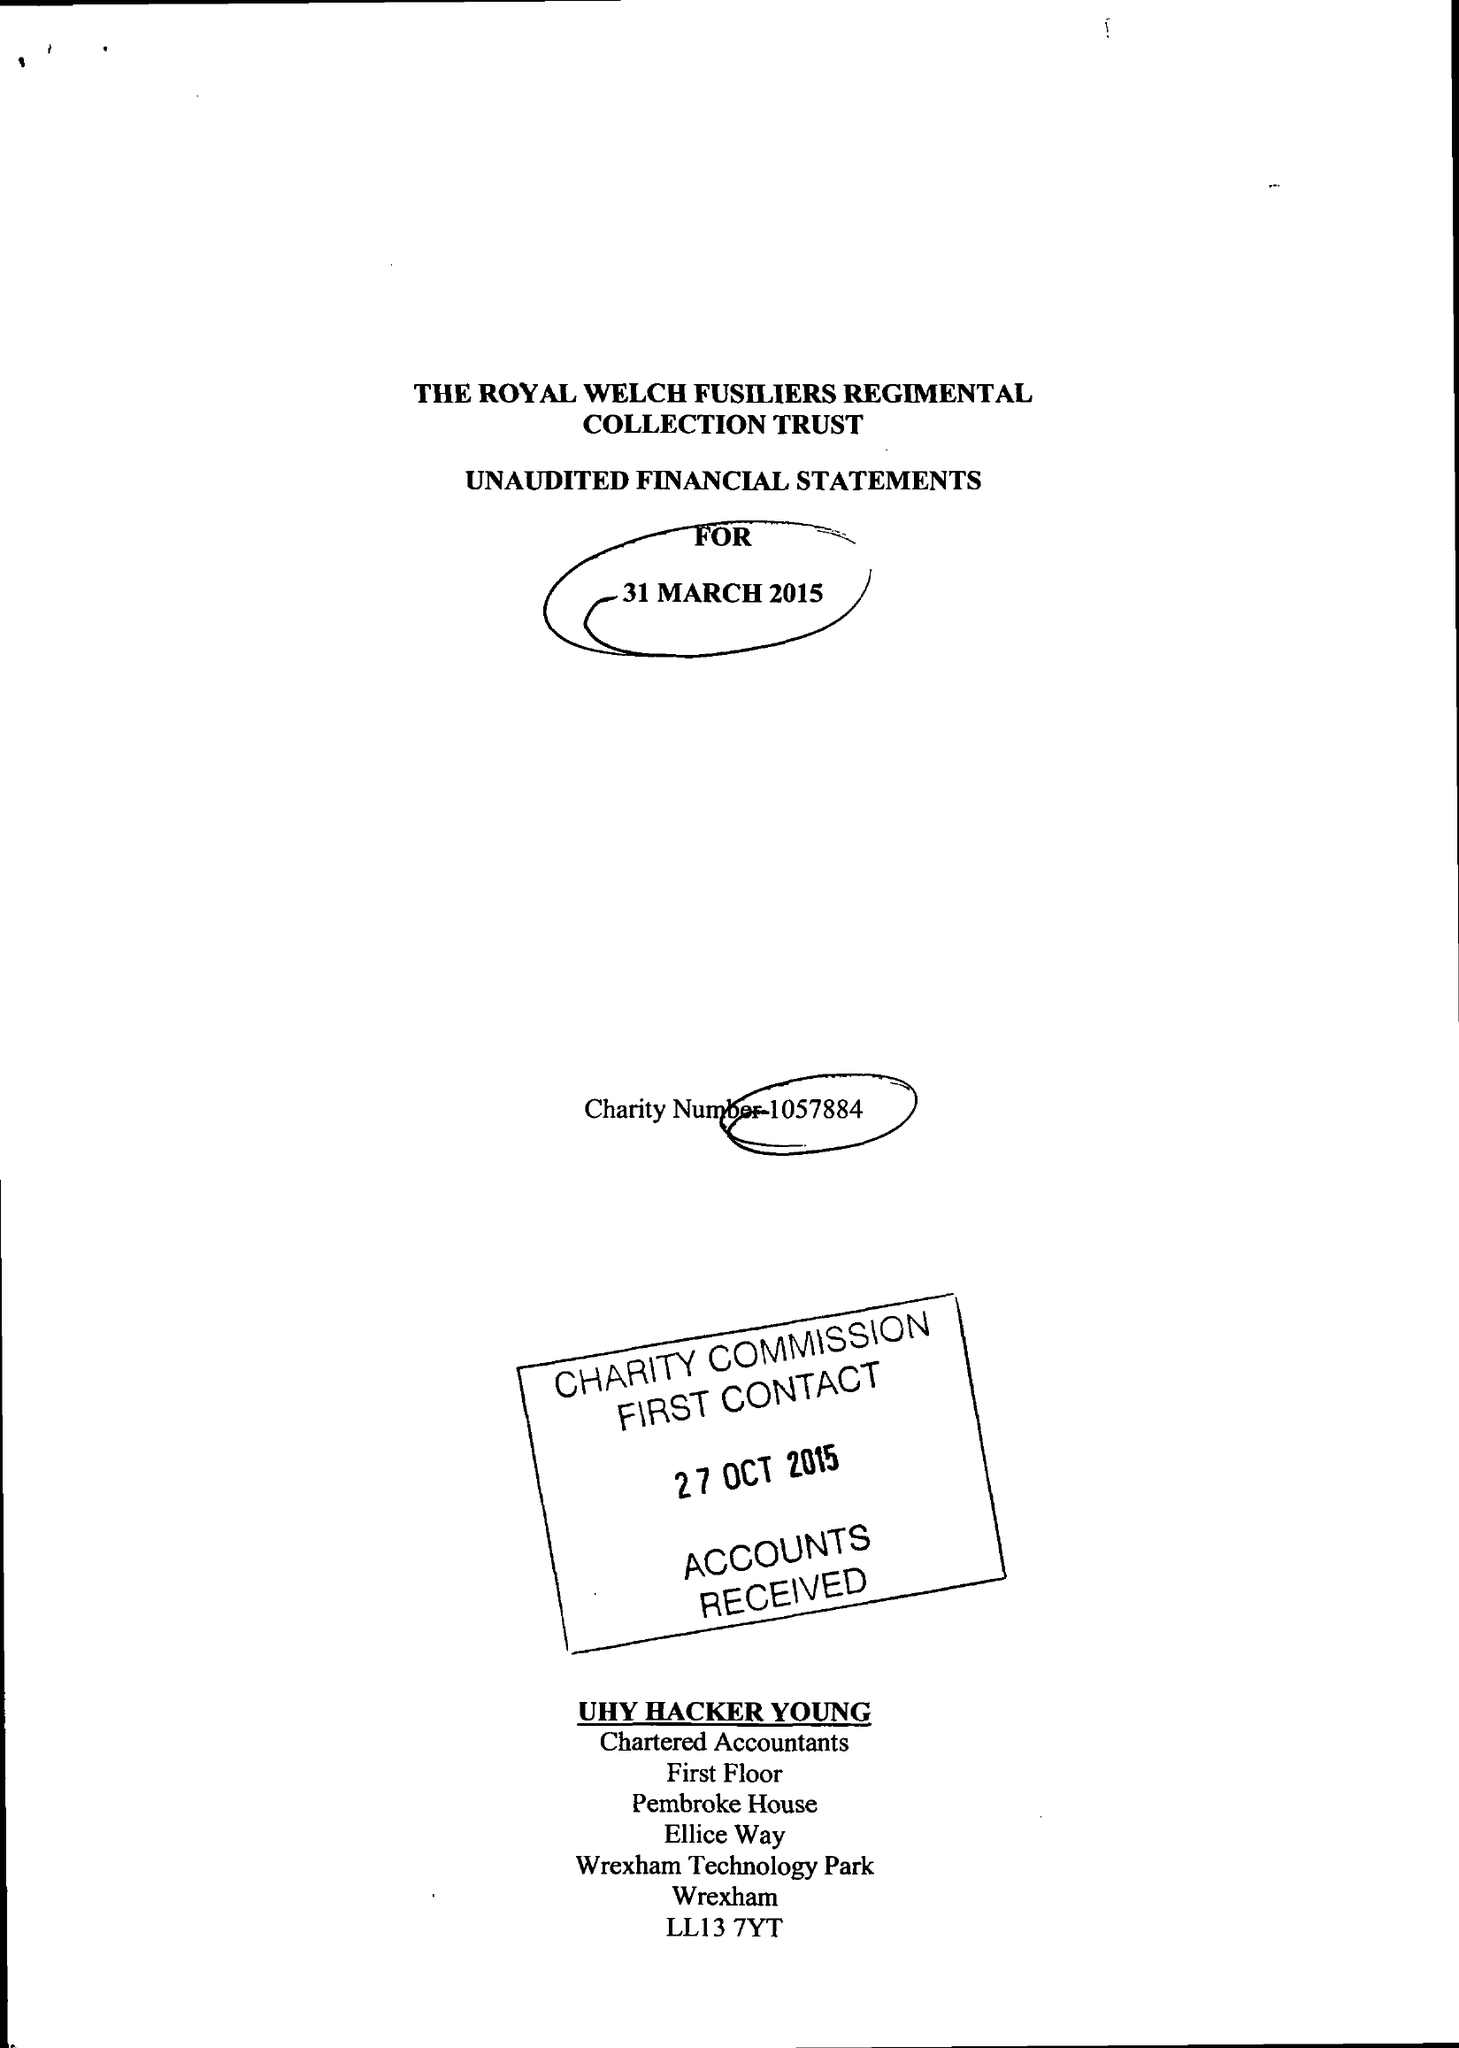What is the value for the address__postcode?
Answer the question using a single word or phrase. LL13 7YT 